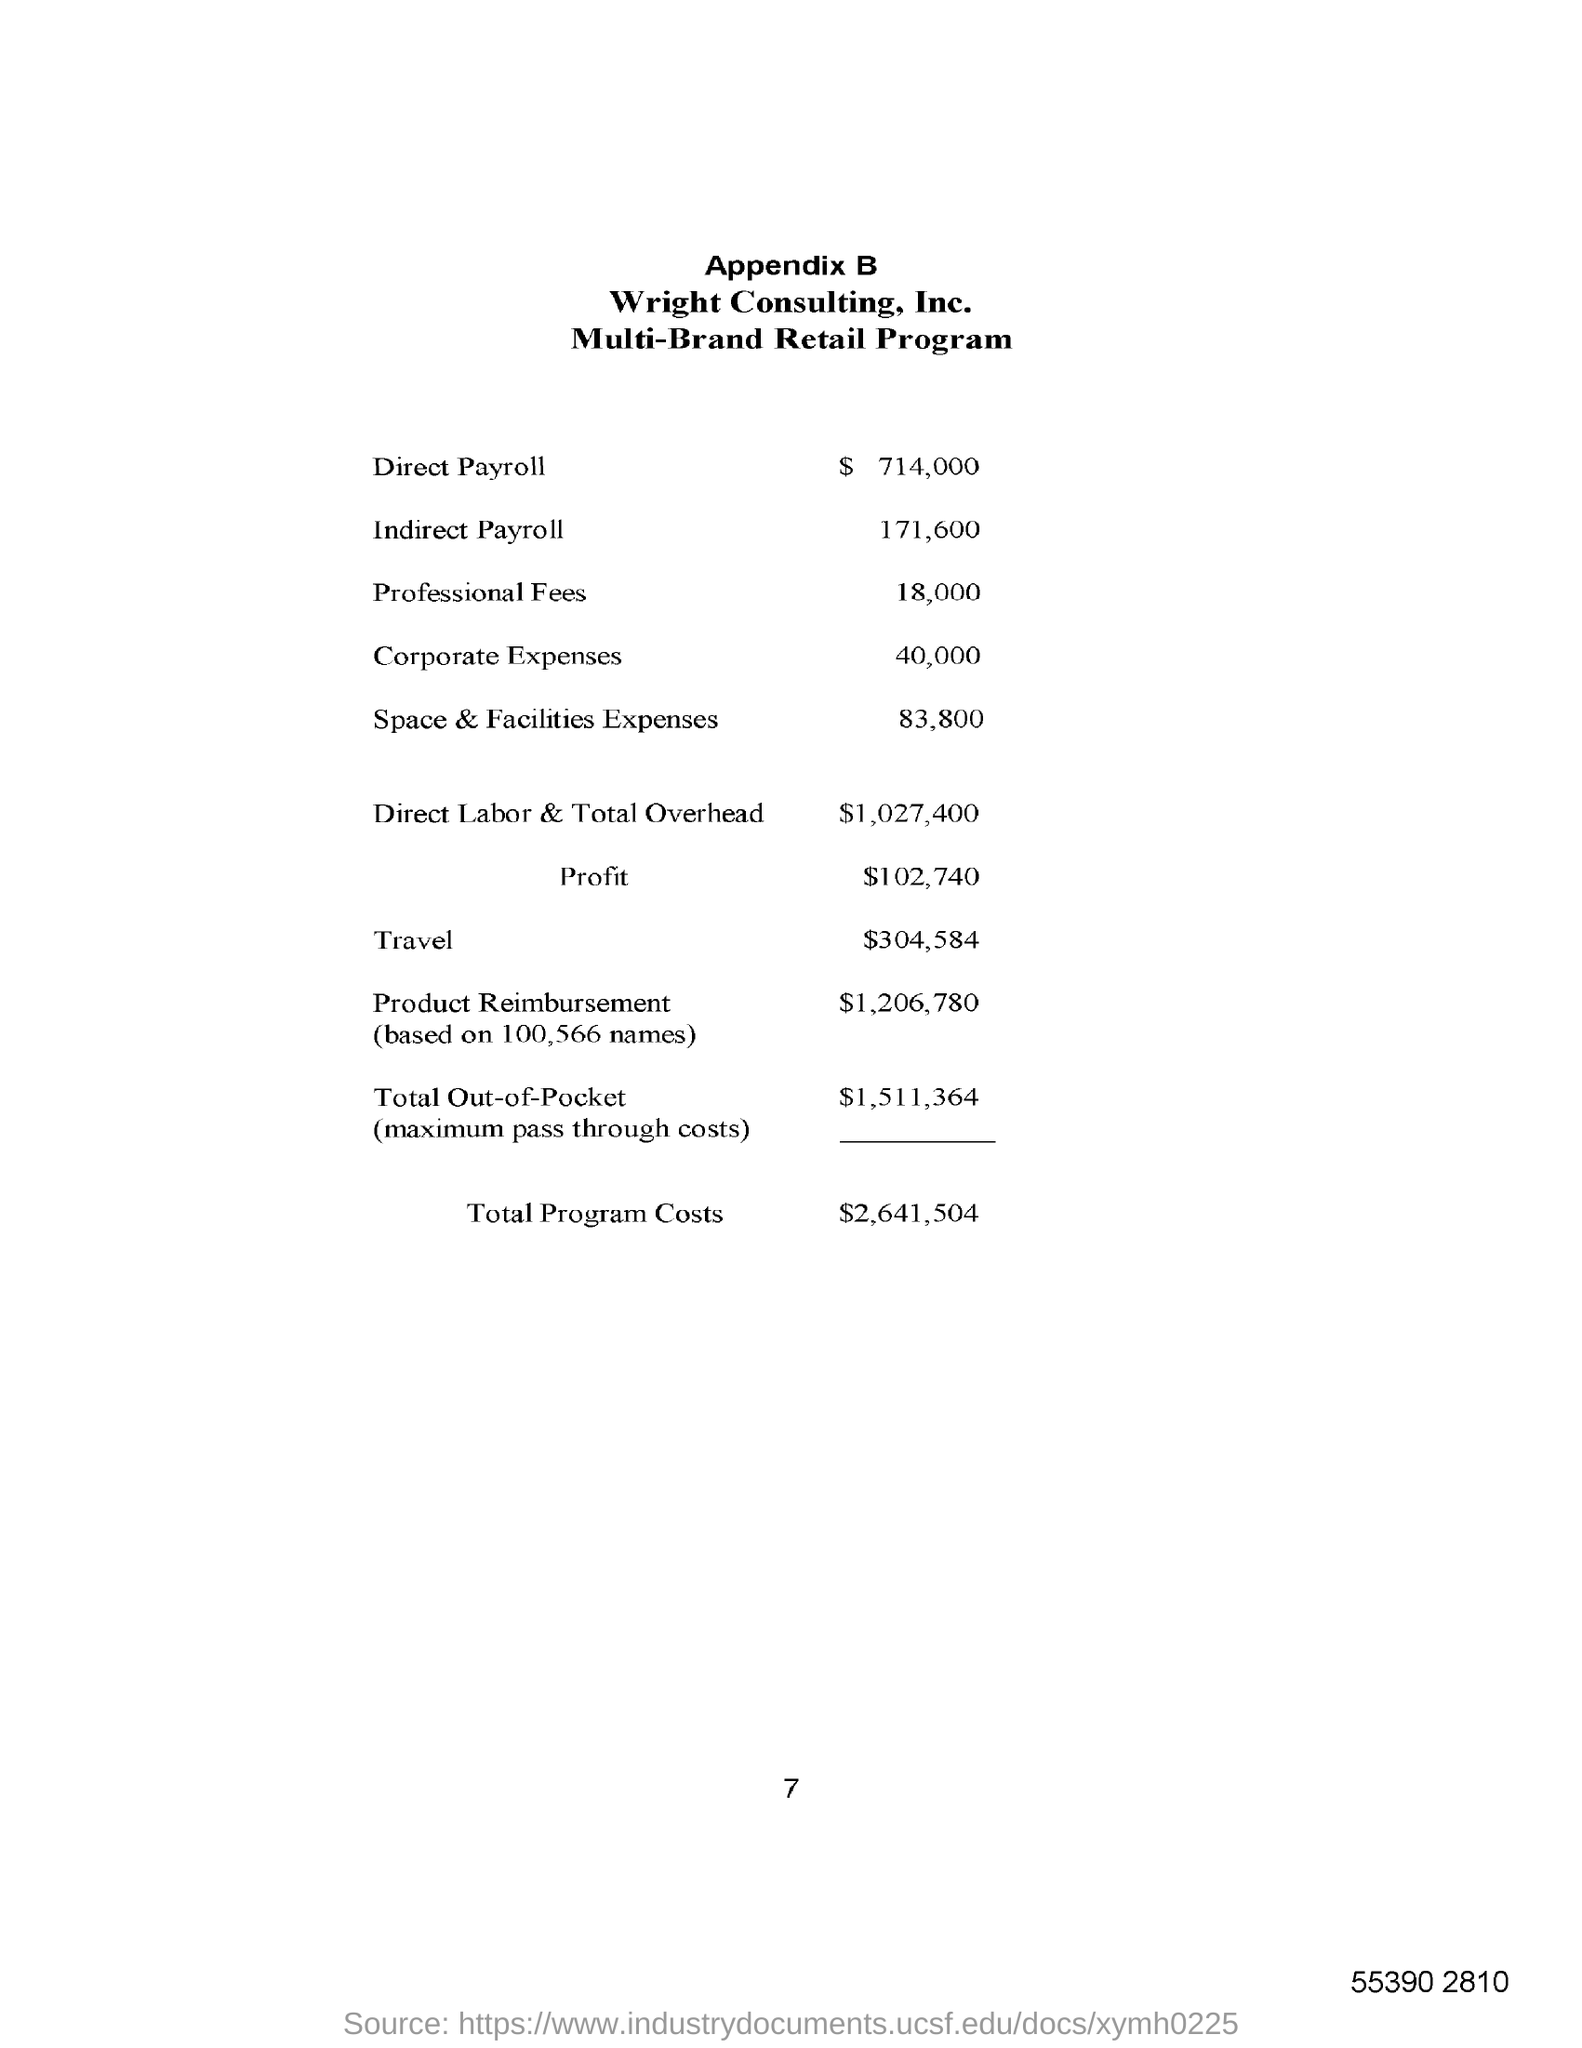What is the Direct Payroll?
Offer a very short reply. $  714,000. What is the Direct Labor Costs & Total Overhead?
Your answer should be very brief. $1,027,400. What is the Total Program Costs?
Give a very brief answer. $2,641,504. What is the Profit?
Offer a very short reply. $102,740. 